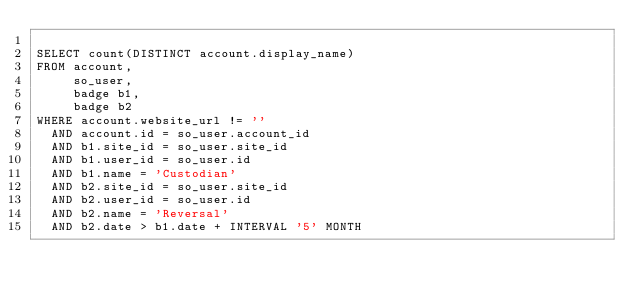Convert code to text. <code><loc_0><loc_0><loc_500><loc_500><_SQL_>
SELECT count(DISTINCT account.display_name)
FROM account,
     so_user,
     badge b1,
     badge b2
WHERE account.website_url != ''
  AND account.id = so_user.account_id
  AND b1.site_id = so_user.site_id
  AND b1.user_id = so_user.id
  AND b1.name = 'Custodian'
  AND b2.site_id = so_user.site_id
  AND b2.user_id = so_user.id
  AND b2.name = 'Reversal'
  AND b2.date > b1.date + INTERVAL '5' MONTH</code> 